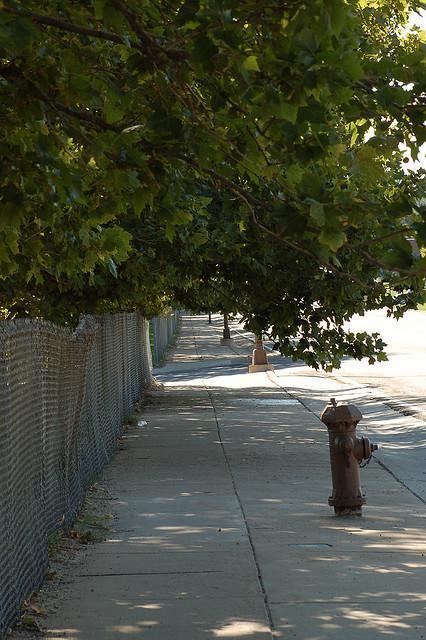How many fire hydrants are pictured?
Give a very brief answer. 1. How many people are in the photo?
Give a very brief answer. 0. 